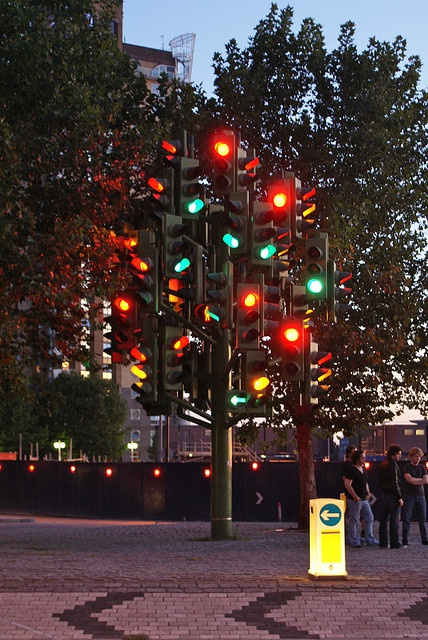Describe the objects in this image and their specific colors. I can see traffic light in black, maroon, gray, and red tones, people in black, maroon, gray, and purple tones, traffic light in black, maroon, red, and gray tones, traffic light in black, maroon, yellow, and brown tones, and traffic light in black, maroon, brown, and red tones in this image. 